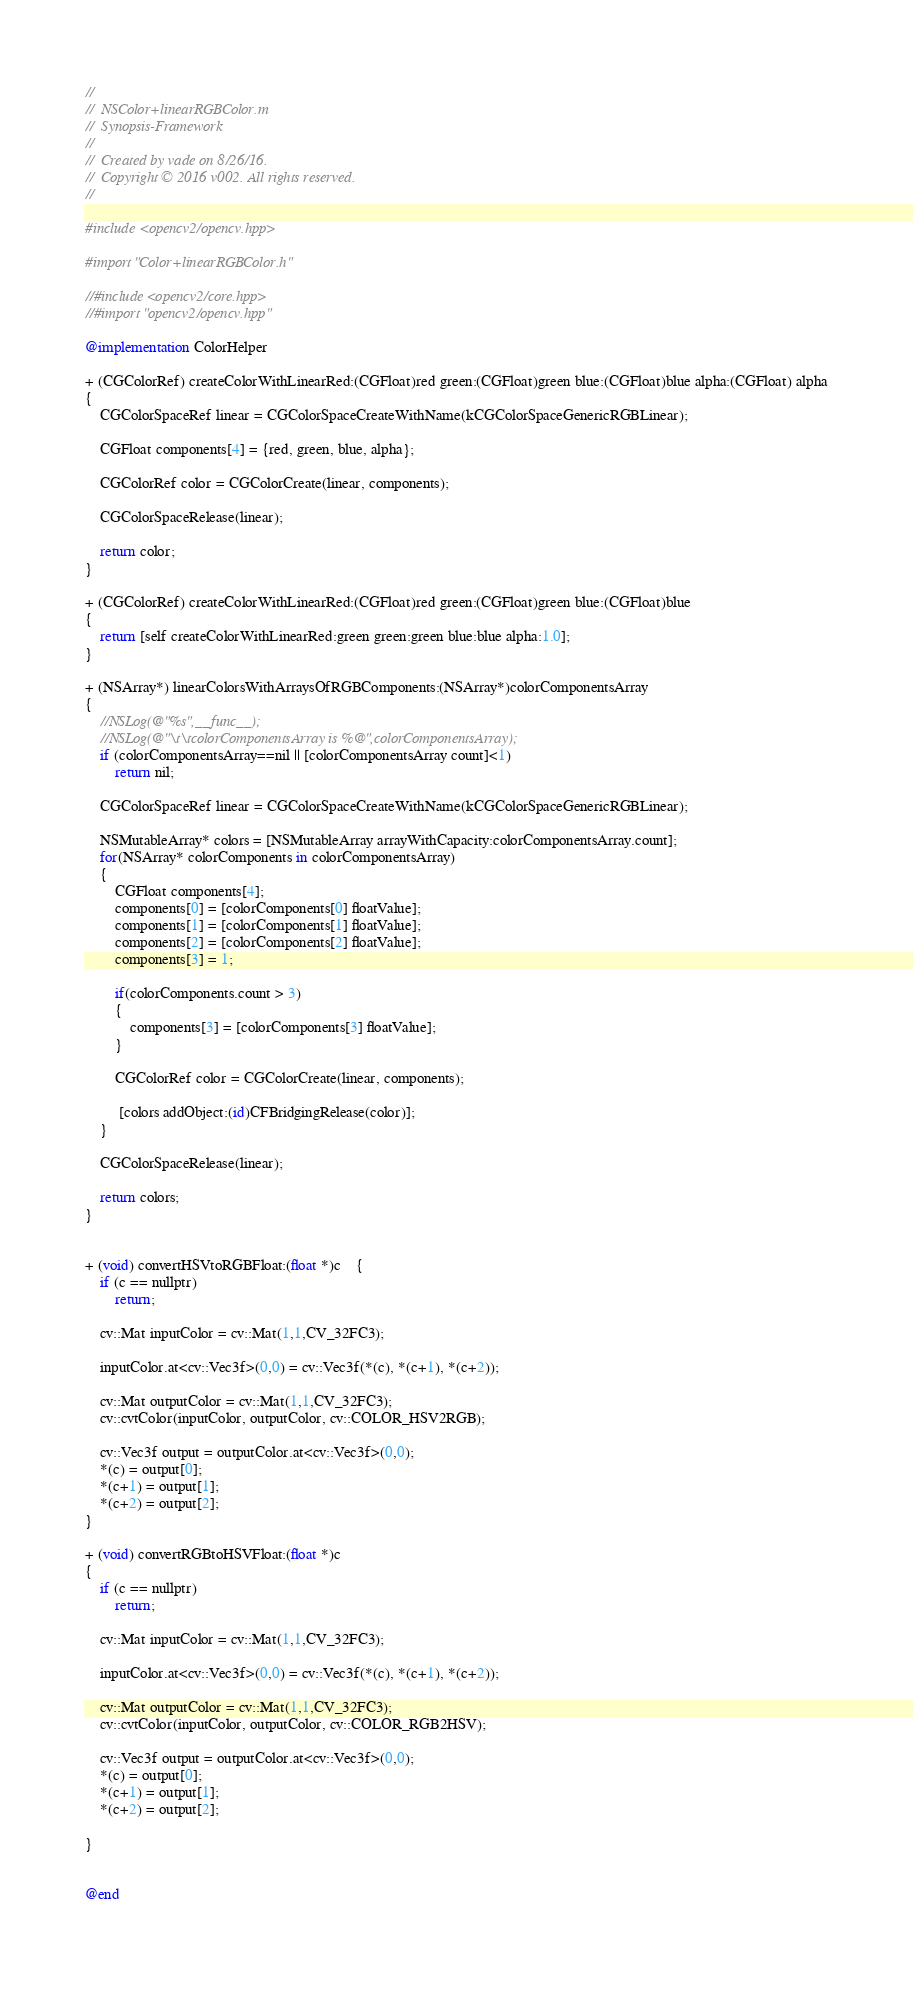<code> <loc_0><loc_0><loc_500><loc_500><_ObjectiveC_>//
//  NSColor+linearRGBColor.m
//  Synopsis-Framework
//
//  Created by vade on 8/26/16.
//  Copyright © 2016 v002. All rights reserved.
//

#include <opencv2/opencv.hpp>

#import "Color+linearRGBColor.h"

//#include <opencv2/core.hpp>
//#import "opencv2/opencv.hpp"

@implementation ColorHelper

+ (CGColorRef) createColorWithLinearRed:(CGFloat)red green:(CGFloat)green blue:(CGFloat)blue alpha:(CGFloat) alpha
{
    CGColorSpaceRef linear = CGColorSpaceCreateWithName(kCGColorSpaceGenericRGBLinear);
    
    CGFloat components[4] = {red, green, blue, alpha};
    
    CGColorRef color = CGColorCreate(linear, components);
    
    CGColorSpaceRelease(linear);

    return color;
}

+ (CGColorRef) createColorWithLinearRed:(CGFloat)red green:(CGFloat)green blue:(CGFloat)blue
{
    return [self createColorWithLinearRed:green green:green blue:blue alpha:1.0];
}

+ (NSArray*) linearColorsWithArraysOfRGBComponents:(NSArray*)colorComponentsArray
{
	//NSLog(@"%s",__func__);
	//NSLog(@"\t\tcolorComponentsArray is %@",colorComponentsArray);
	if (colorComponentsArray==nil || [colorComponentsArray count]<1)
		return nil;
	
    CGColorSpaceRef linear = CGColorSpaceCreateWithName(kCGColorSpaceGenericRGBLinear);

    NSMutableArray* colors = [NSMutableArray arrayWithCapacity:colorComponentsArray.count];
    for(NSArray* colorComponents in colorComponentsArray)
    {
        CGFloat components[4];
        components[0] = [colorComponents[0] floatValue];
        components[1] = [colorComponents[1] floatValue];
        components[2] = [colorComponents[2] floatValue];
        components[3] = 1;
        
        if(colorComponents.count > 3)
        {
            components[3] = [colorComponents[3] floatValue];
        }
        
        CGColorRef color = CGColorCreate(linear, components);

         [colors addObject:(id)CFBridgingRelease(color)];
    }
    
    CGColorSpaceRelease(linear);

    return colors;
}


+ (void) convertHSVtoRGBFloat:(float *)c	{
	if (c == nullptr)
		return;
	
	cv::Mat inputColor = cv::Mat(1,1,CV_32FC3);
    
    inputColor.at<cv::Vec3f>(0,0) = cv::Vec3f(*(c), *(c+1), *(c+2));
    
    cv::Mat outputColor = cv::Mat(1,1,CV_32FC3);
	cv::cvtColor(inputColor, outputColor, cv::COLOR_HSV2RGB);

    cv::Vec3f output = outputColor.at<cv::Vec3f>(0,0);
	*(c) = output[0];
	*(c+1) = output[1];
	*(c+2) = output[2];
}

+ (void) convertRGBtoHSVFloat:(float *)c
{
	if (c == nullptr)
		return;
	
    cv::Mat inputColor = cv::Mat(1,1,CV_32FC3);
    
    inputColor.at<cv::Vec3f>(0,0) = cv::Vec3f(*(c), *(c+1), *(c+2));
    
    cv::Mat outputColor = cv::Mat(1,1,CV_32FC3);
    cv::cvtColor(inputColor, outputColor, cv::COLOR_RGB2HSV);
    
    cv::Vec3f output = outputColor.at<cv::Vec3f>(0,0);
    *(c) = output[0];
    *(c+1) = output[1];
    *(c+2) = output[2];

}


@end
</code> 